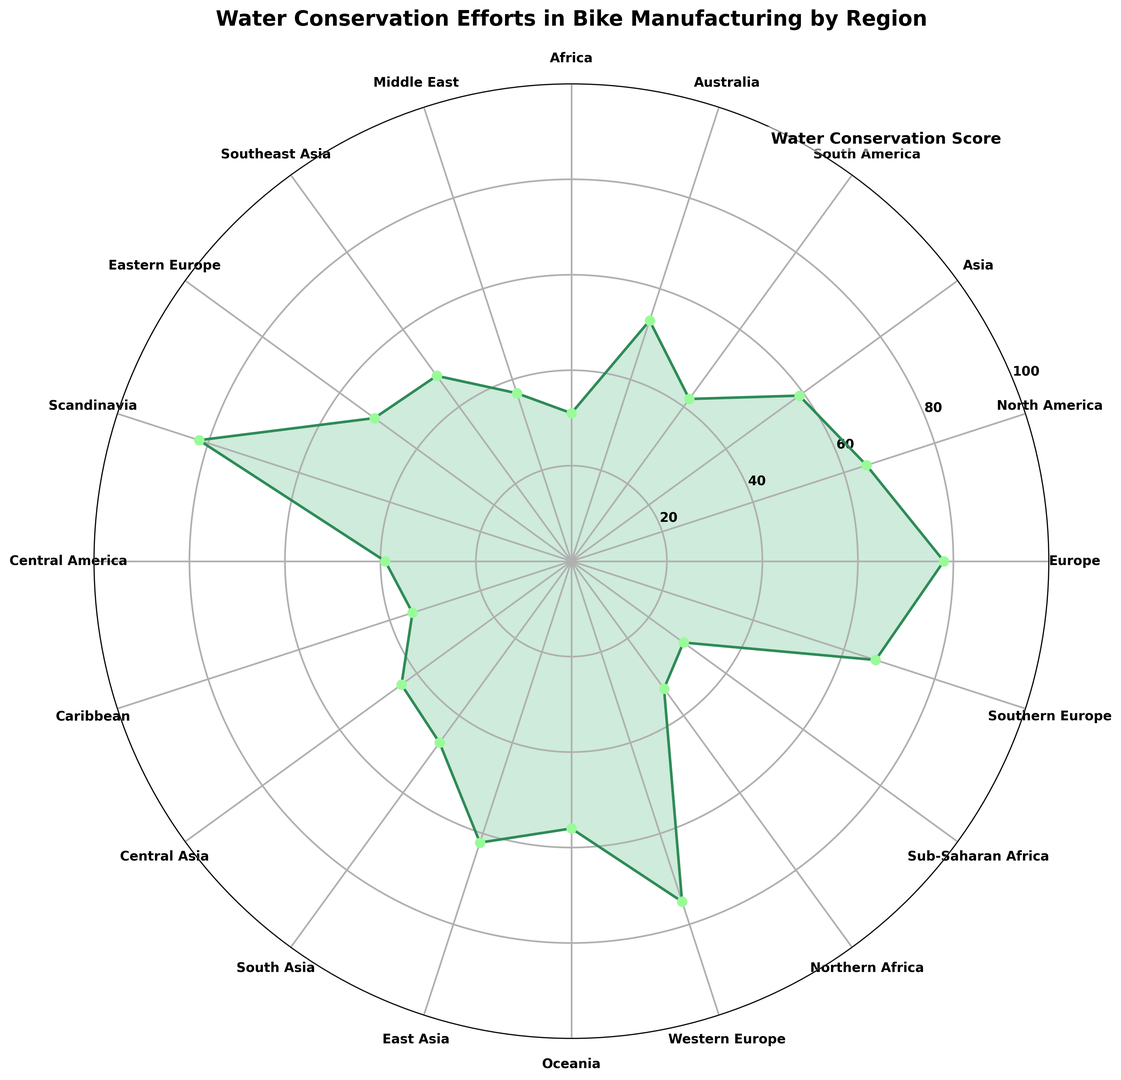Which region has the highest water conservation score? The region with the highest water conservation score can be identified by the longest petal in the chart. In this case, Scandinavia has the highest score.
Answer: Scandinavia Which region has the lowest water conservation score? The region with the lowest water conservation score can be identified by the shortest petal in the chart. Sub-Saharan Africa has the lowest score.
Answer: Sub-Saharan Africa How do the water conservation scores of North America and Western Europe compare? To compare their scores, look for the lengths of the petals for North America and Western Europe. North America has a score of 65, while Western Europe has a score of 75. Hence, Western Europe has a higher score than North America.
Answer: Western Europe has a higher score What is the difference between the water conservation scores of Europe and Southern Europe? Europe has a water conservation score of 78, and Southern Europe has a score of 67. The difference can be calculated by subtracting 67 from 78.
Answer: 11 Is the water conservation score of South America higher or lower than that of Australia? Compare the lengths of the petals for South America and Australia. South America's score is 42, while Australia's score is 53. Hence, South America's score is lower than Australia's.
Answer: Lower What is the average water conservation score of the three regions with the highest scores? Identify the three regions with the highest scores: Scandinavia (82), Europe (78), and Western Europe (75). Calculate the average by summing these scores (82 + 78 + 75 = 235) and dividing by 3.
Answer: 78.33 Which region has a water conservation score closest to 50? Look for the region whose petal length visually aligns closest to the 50 mark on the radial axis. Eastern Europe has a score of 51, closest to 50.
Answer: Eastern Europe How many regions have water conservation scores above 60? Count the petals that extend beyond the 60 mark on the radial axis. Europe, North America, Scandinavia, Western Europe, Southern Europe, and East Asia each have scores above 60.
Answer: 6 regions How do the water conservation scores of Caribbean and Central America compare? Look for the petals corresponding to the Caribbean and Central America. The Caribbean has a score of 35, and Central America has a score of 39.
Answer: Central America has a higher score Is the water conservation score of Africa higher than that of Northern Africa? Compare the scores of Africa and Northern Africa. Africa (represented as Sub-Saharan Africa) has a score of 29, while Northern Africa has a score of 33.
Answer: Northern Africa has a higher score 